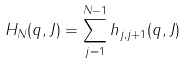<formula> <loc_0><loc_0><loc_500><loc_500>H _ { N } ( q , J ) = \sum _ { j = 1 } ^ { N - 1 } h _ { j , j + 1 } ( q , J )</formula> 